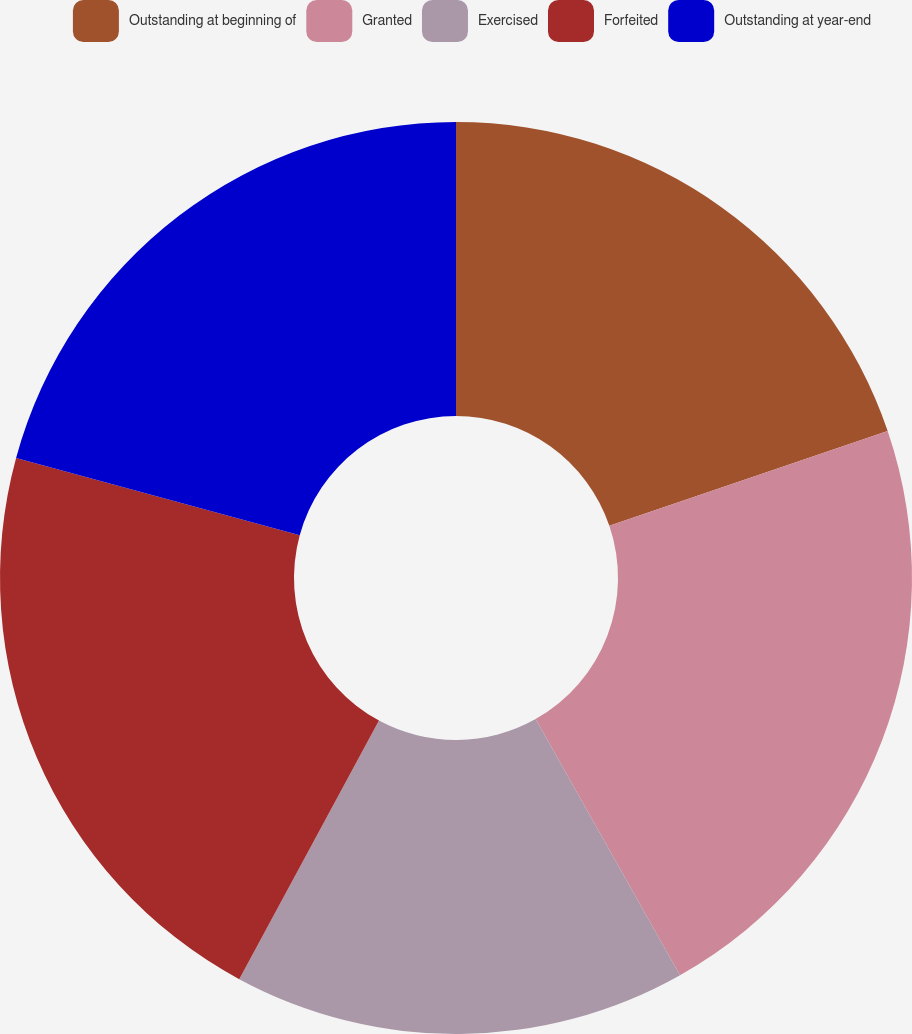Convert chart to OTSL. <chart><loc_0><loc_0><loc_500><loc_500><pie_chart><fcel>Outstanding at beginning of<fcel>Granted<fcel>Exercised<fcel>Forfeited<fcel>Outstanding at year-end<nl><fcel>19.78%<fcel>22.05%<fcel>16.06%<fcel>21.36%<fcel>20.76%<nl></chart> 